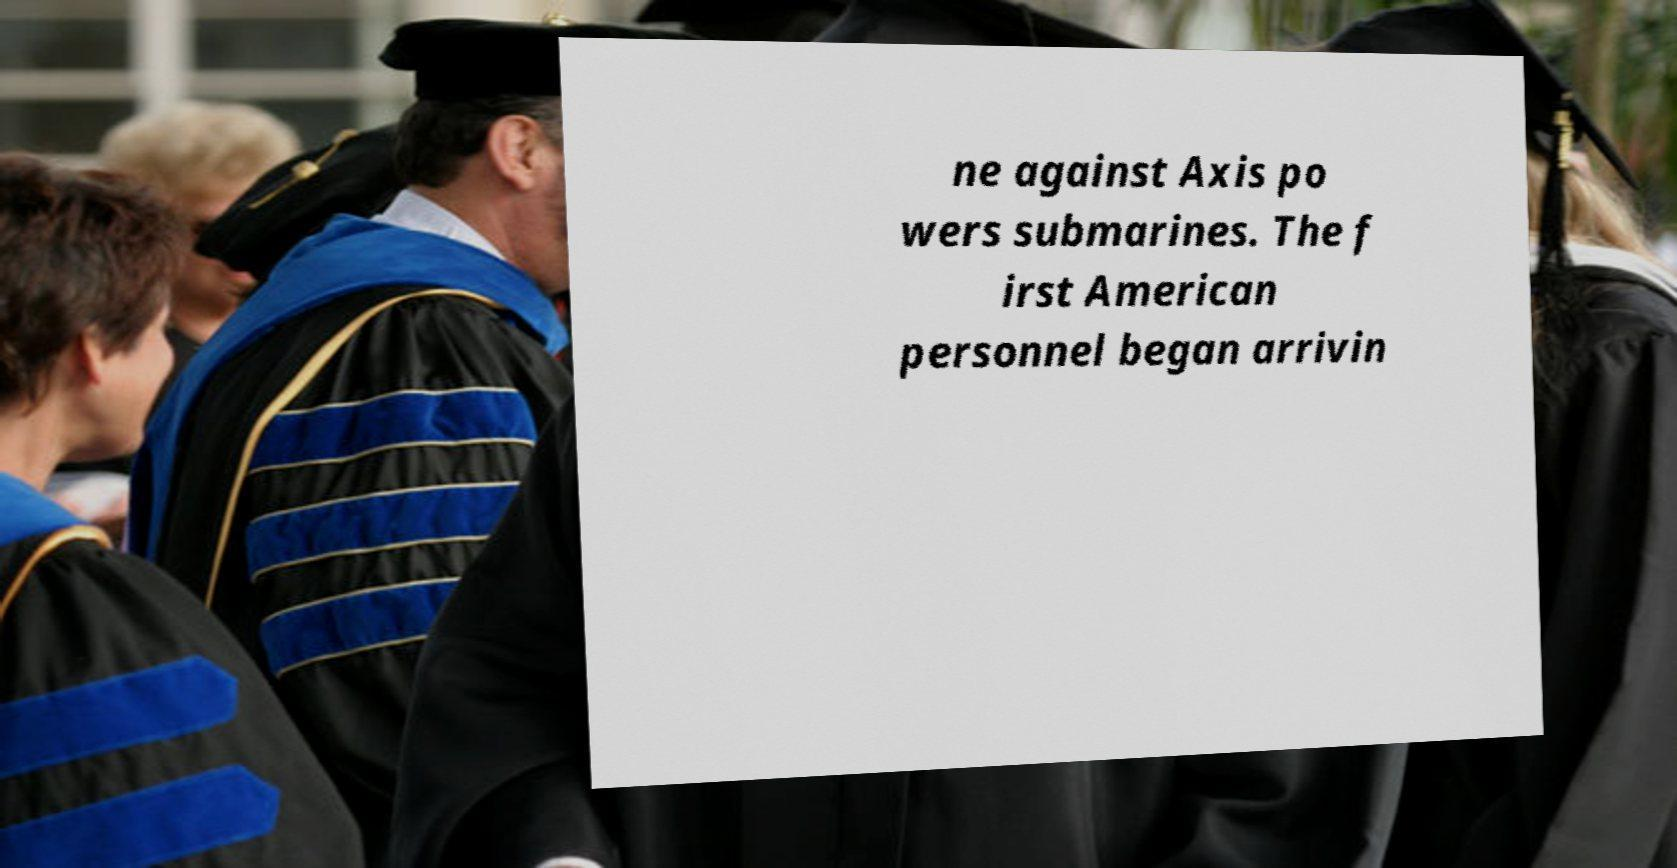Could you assist in decoding the text presented in this image and type it out clearly? ne against Axis po wers submarines. The f irst American personnel began arrivin 